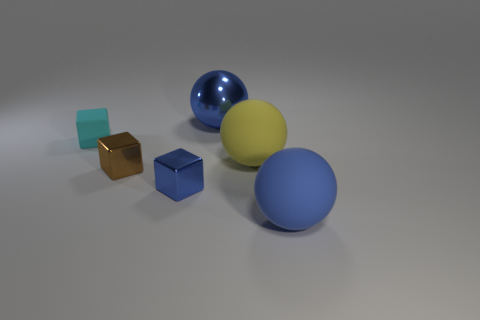Subtract all cyan cylinders. How many blue spheres are left? 2 Subtract all shiny blocks. How many blocks are left? 1 Add 4 yellow balls. How many objects exist? 10 Add 2 big blue metallic things. How many big blue metallic things exist? 3 Subtract 0 brown spheres. How many objects are left? 6 Subtract all cyan blocks. Subtract all big yellow balls. How many objects are left? 4 Add 5 small shiny things. How many small shiny things are left? 7 